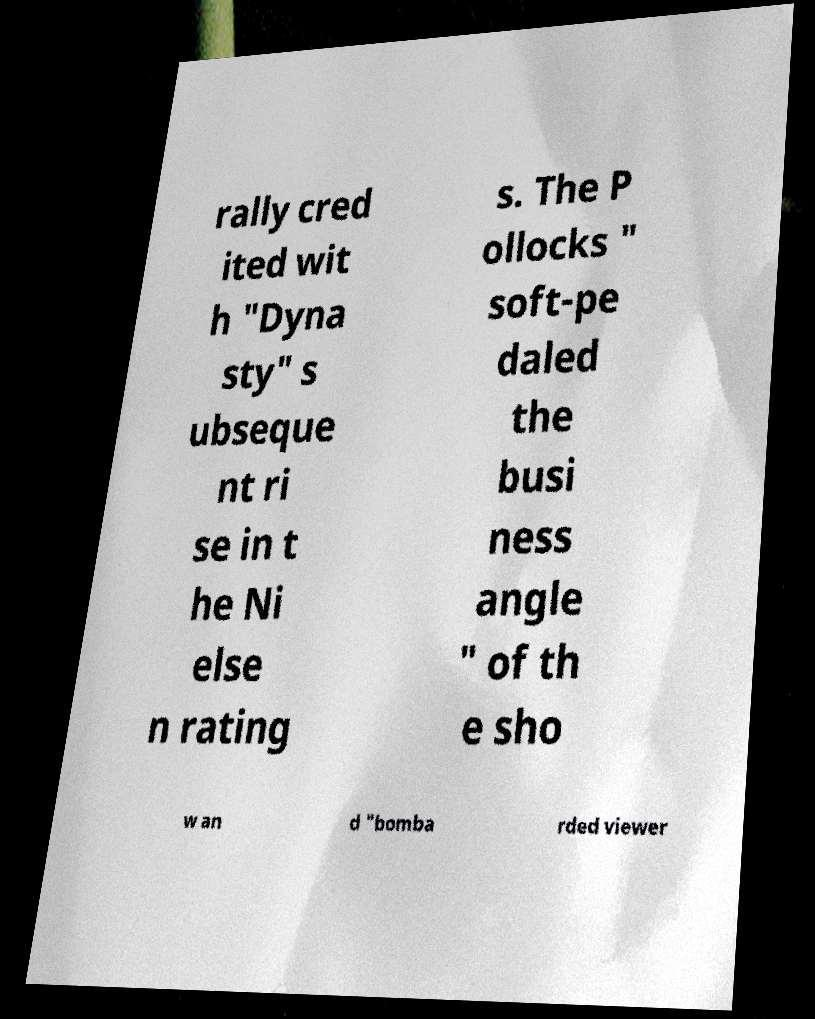For documentation purposes, I need the text within this image transcribed. Could you provide that? rally cred ited wit h "Dyna sty" s ubseque nt ri se in t he Ni else n rating s. The P ollocks " soft-pe daled the busi ness angle " of th e sho w an d "bomba rded viewer 